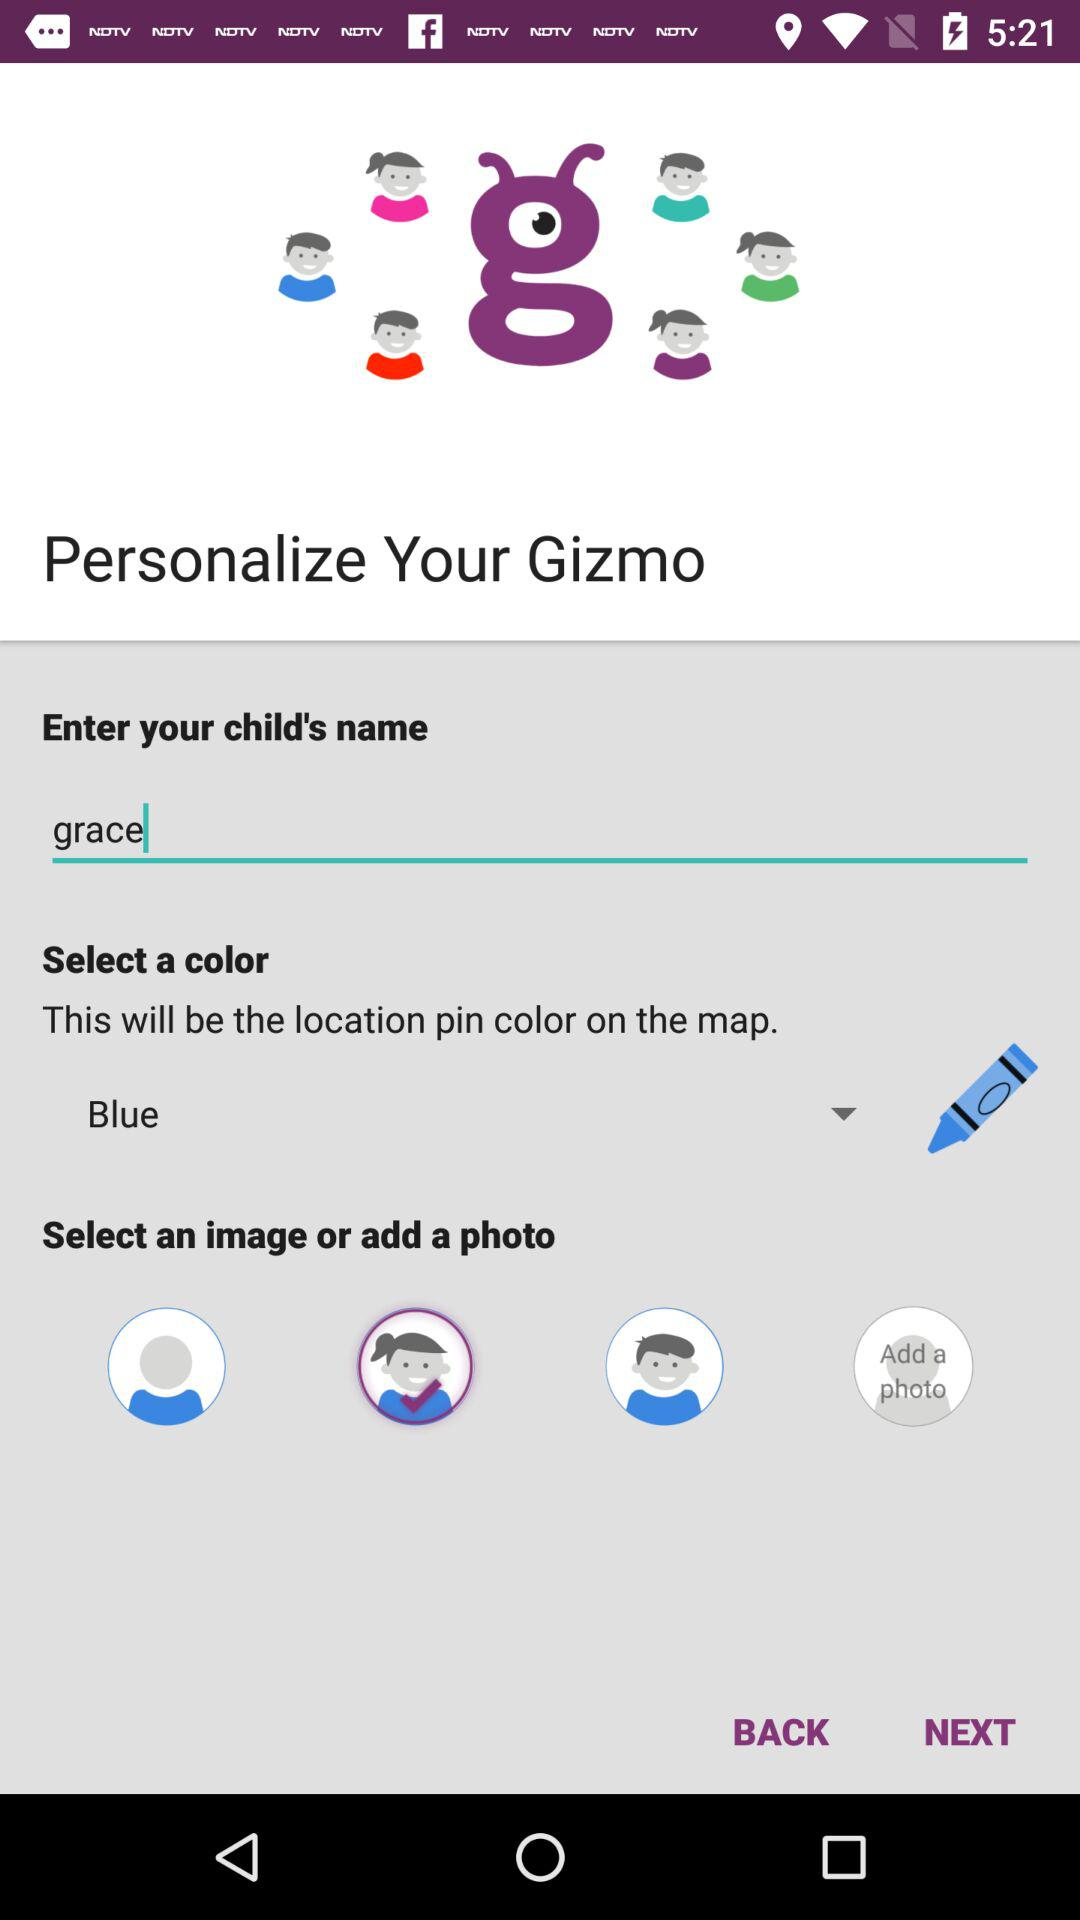What will be the location pin color on the map? The location pin color on the map will be blue. 